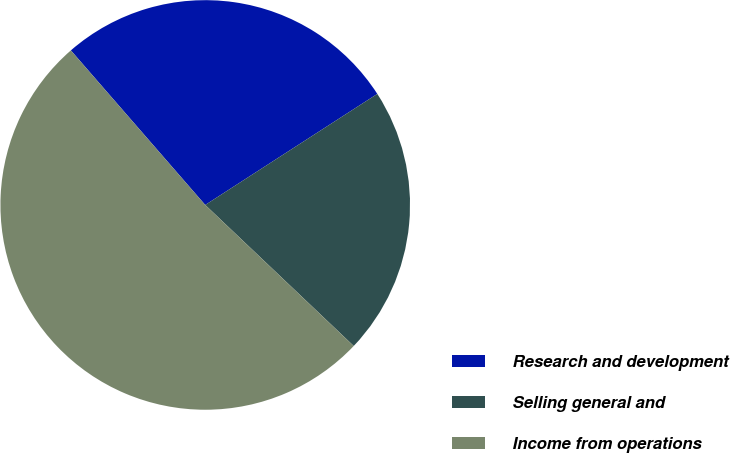Convert chart to OTSL. <chart><loc_0><loc_0><loc_500><loc_500><pie_chart><fcel>Research and development<fcel>Selling general and<fcel>Income from operations<nl><fcel>27.27%<fcel>21.21%<fcel>51.52%<nl></chart> 